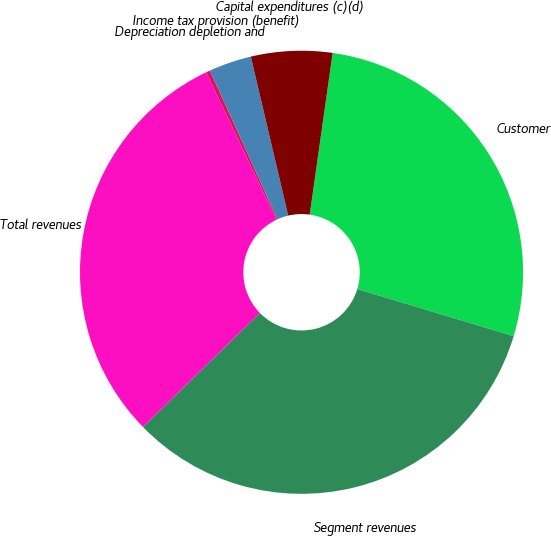Convert chart to OTSL. <chart><loc_0><loc_0><loc_500><loc_500><pie_chart><fcel>Customer<fcel>Segment revenues<fcel>Total revenues<fcel>Depreciation depletion and<fcel>Income tax provision (benefit)<fcel>Capital expenditures (c)(d)<nl><fcel>27.42%<fcel>33.04%<fcel>30.23%<fcel>0.3%<fcel>3.11%<fcel>5.92%<nl></chart> 